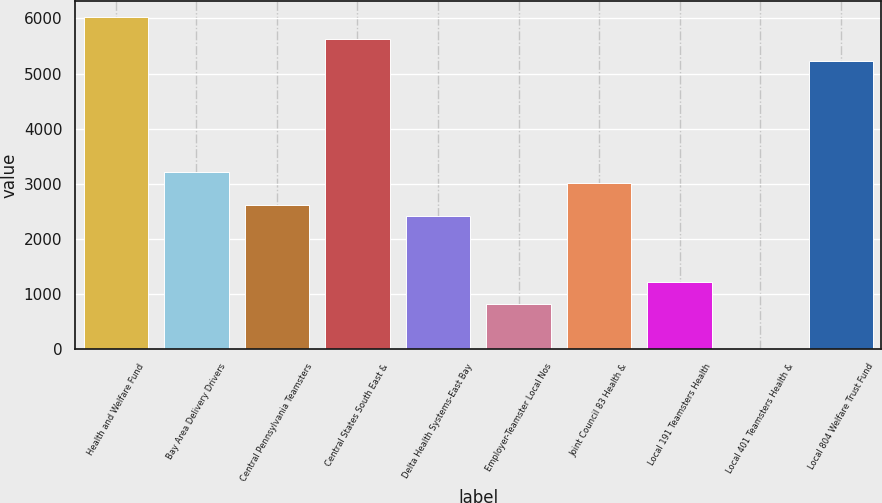<chart> <loc_0><loc_0><loc_500><loc_500><bar_chart><fcel>Health and Welfare Fund<fcel>Bay Area Delivery Drivers<fcel>Central Pennsylvania Teamsters<fcel>Central States South East &<fcel>Delta Health Systems-East Bay<fcel>Employer-Teamster Local Nos<fcel>Joint Council 83 Health &<fcel>Local 191 Teamsters Health<fcel>Local 401 Teamsters Health &<fcel>Local 804 Welfare Trust Fund<nl><fcel>6021<fcel>3214<fcel>2612.5<fcel>5620<fcel>2412<fcel>808<fcel>3013.5<fcel>1209<fcel>6<fcel>5219<nl></chart> 